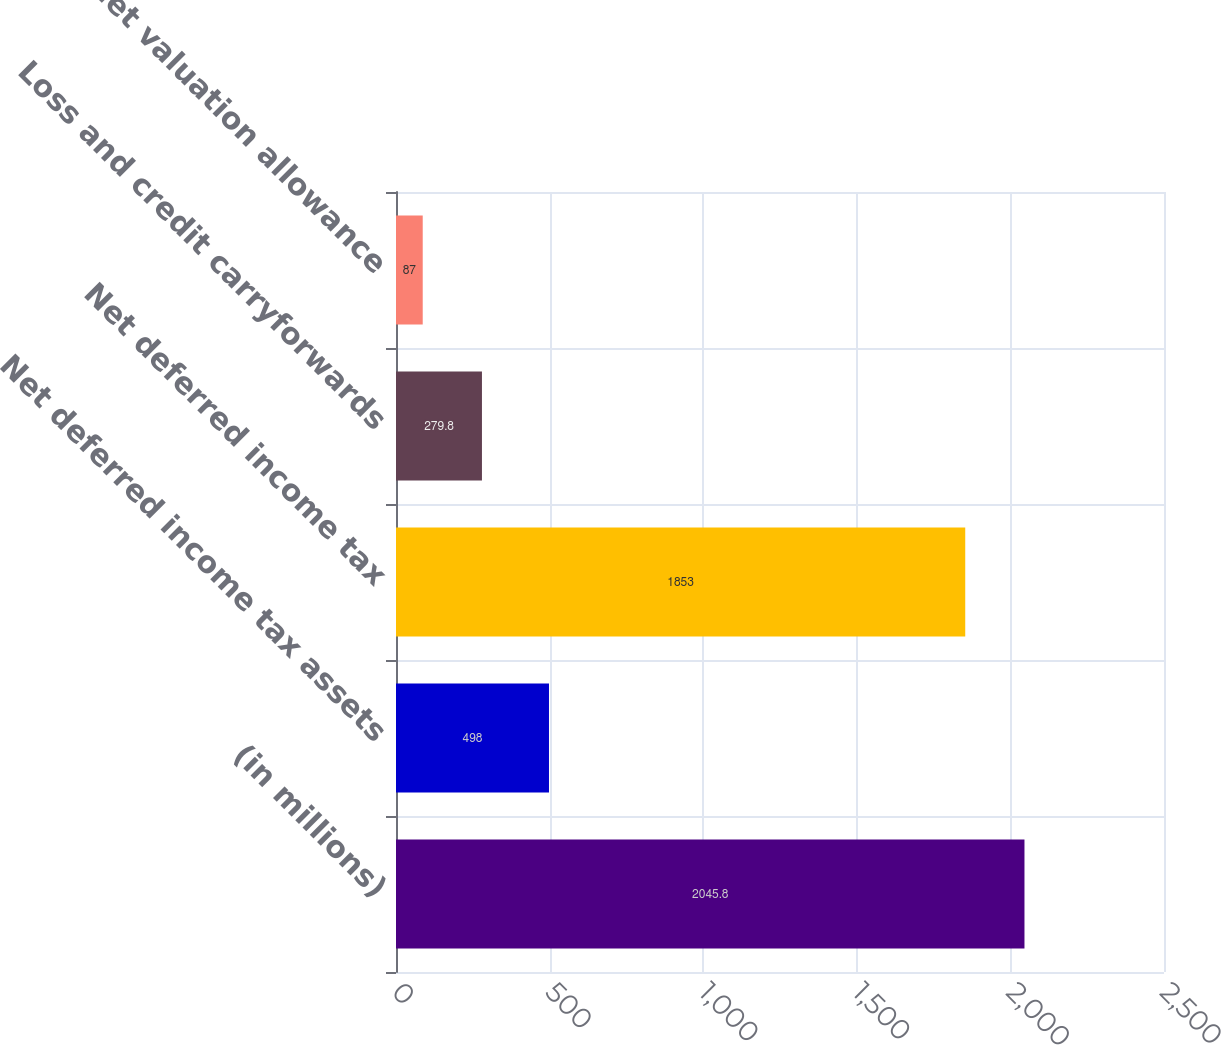Convert chart to OTSL. <chart><loc_0><loc_0><loc_500><loc_500><bar_chart><fcel>(in millions)<fcel>Net deferred income tax assets<fcel>Net deferred income tax<fcel>Loss and credit carryforwards<fcel>Net valuation allowance<nl><fcel>2045.8<fcel>498<fcel>1853<fcel>279.8<fcel>87<nl></chart> 